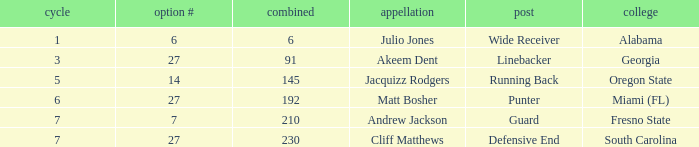Which designation had more than 5 rounds and functioned as a defensive end? Cliff Matthews. 